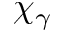<formula> <loc_0><loc_0><loc_500><loc_500>\chi _ { \gamma }</formula> 